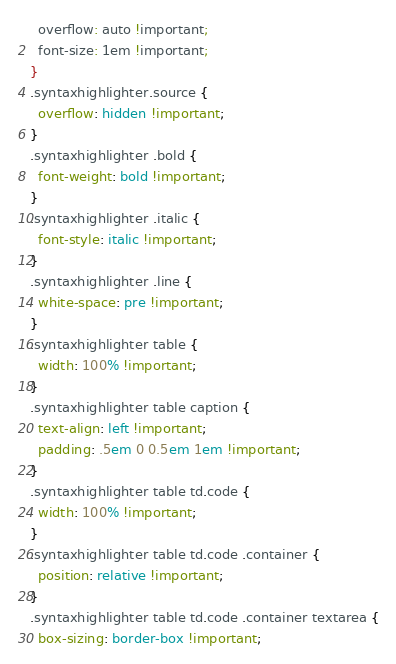<code> <loc_0><loc_0><loc_500><loc_500><_CSS_>  overflow: auto !important;
  font-size: 1em !important;
}
.syntaxhighlighter.source {
  overflow: hidden !important;
}
.syntaxhighlighter .bold {
  font-weight: bold !important;
}
.syntaxhighlighter .italic {
  font-style: italic !important;
}
.syntaxhighlighter .line {
  white-space: pre !important;
}
.syntaxhighlighter table {
  width: 100% !important;
}
.syntaxhighlighter table caption {
  text-align: left !important;
  padding: .5em 0 0.5em 1em !important;
}
.syntaxhighlighter table td.code {
  width: 100% !important;
}
.syntaxhighlighter table td.code .container {
  position: relative !important;
}
.syntaxhighlighter table td.code .container textarea {
  box-sizing: border-box !important;</code> 